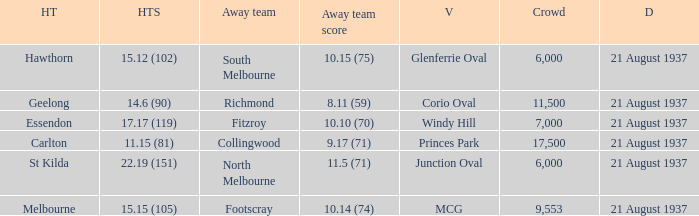Where did Richmond play? Corio Oval. 